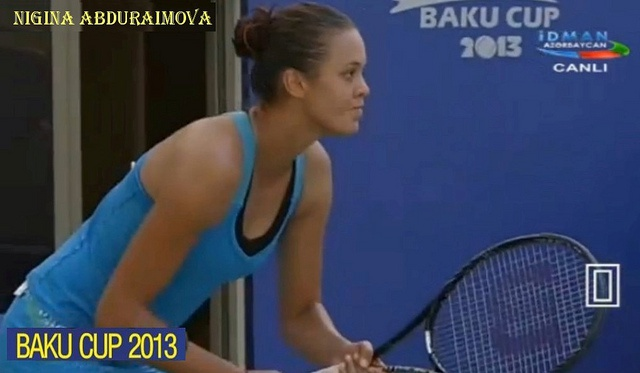Describe the objects in this image and their specific colors. I can see people in black, maroon, blue, and gray tones and tennis racket in black, navy, darkblue, and blue tones in this image. 